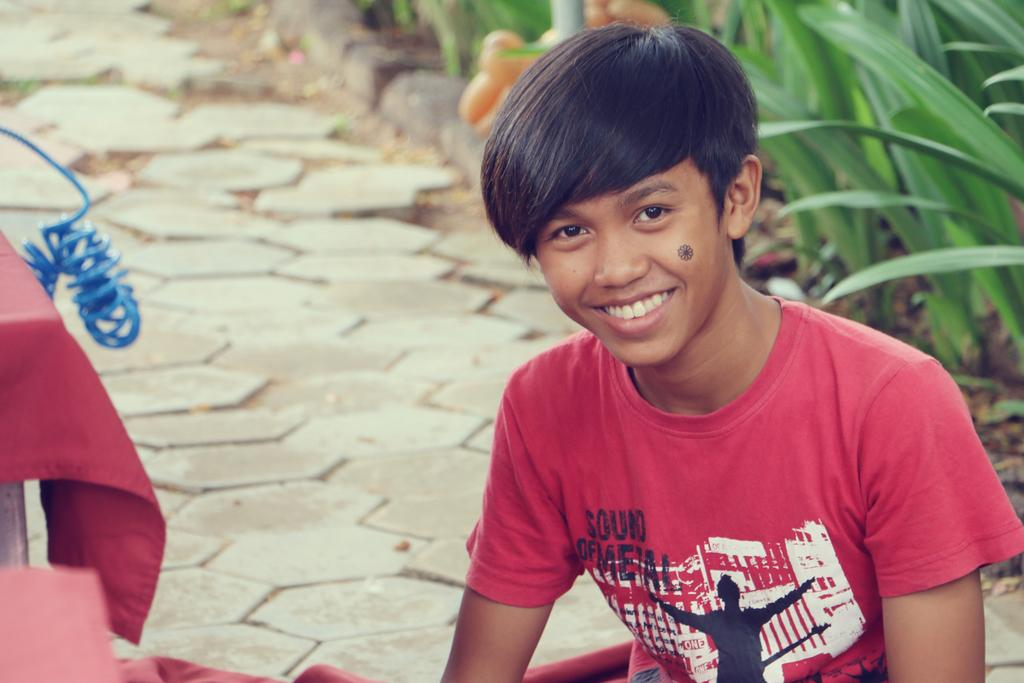What is the person in the image doing? There is a person sitting in the image. What can be seen on the right side of the image? There are plants on the right side of the image. What is located on the left side of the image? There is a table on the left side of the image. How is the table decorated or covered? The table is covered by a cloth. What type of knot is tied on the window in the image? There is no window or knot present in the image. 